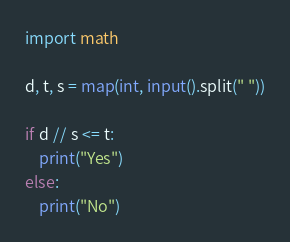Convert code to text. <code><loc_0><loc_0><loc_500><loc_500><_Python_>import math

d, t, s = map(int, input().split(" "))

if d // s <= t:
    print("Yes")
else:
    print("No")</code> 